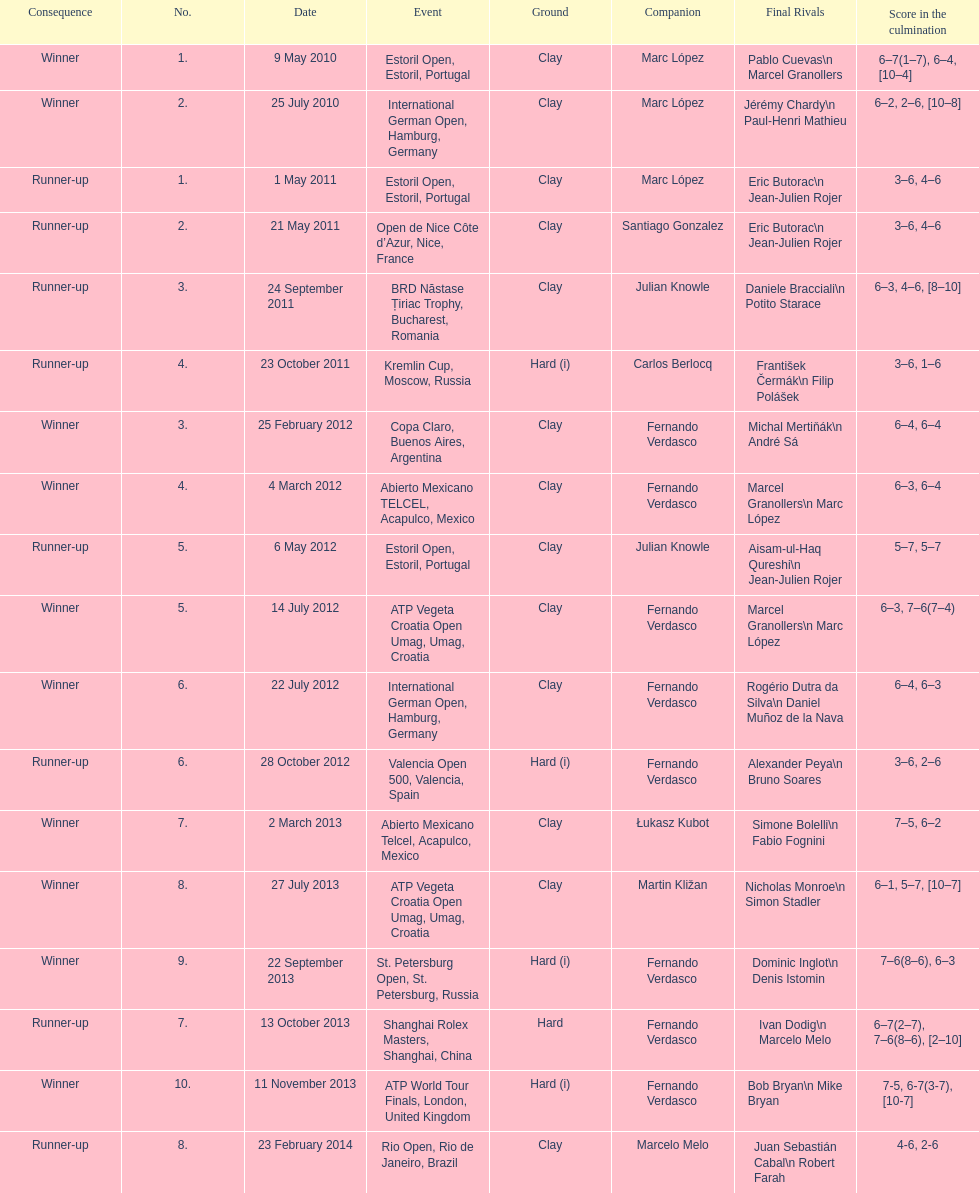How many partners from spain are listed? 2. 